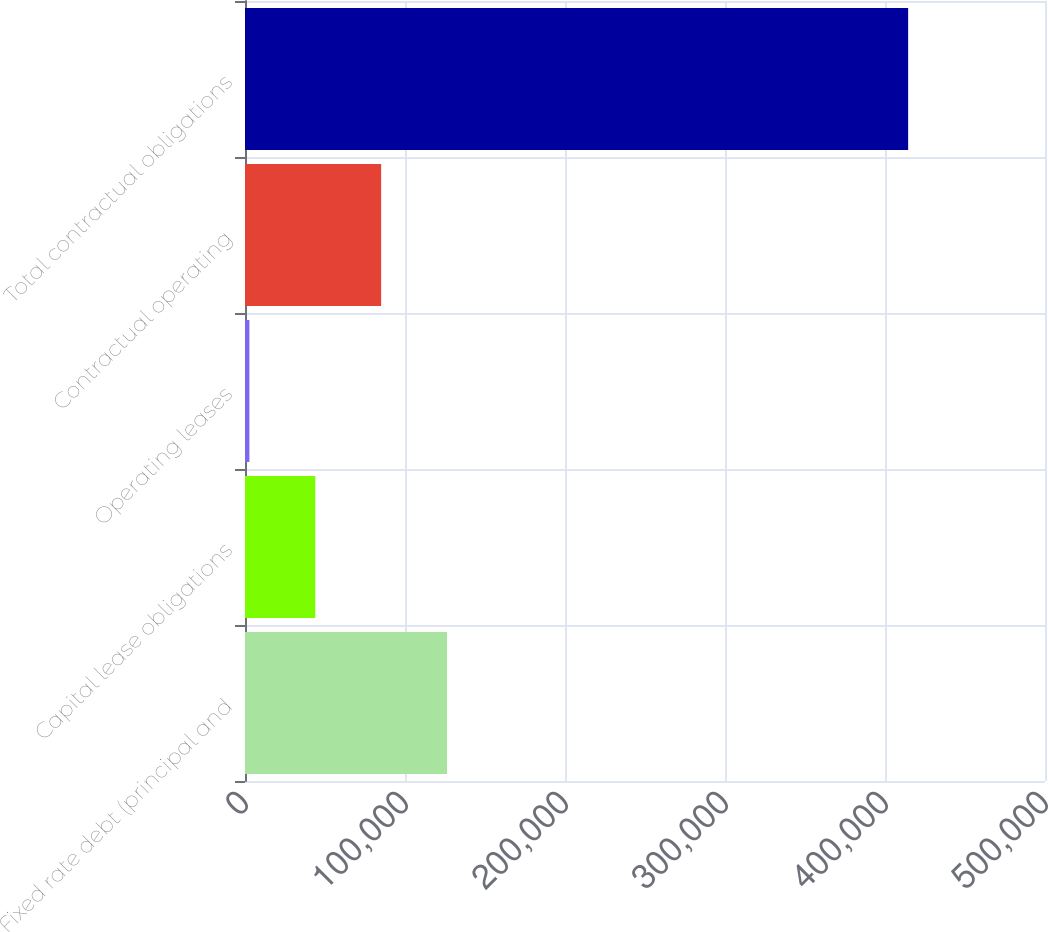Convert chart. <chart><loc_0><loc_0><loc_500><loc_500><bar_chart><fcel>Fixed rate debt (principal and<fcel>Capital lease obligations<fcel>Operating leases<fcel>Contractual operating<fcel>Total contractual obligations<nl><fcel>126265<fcel>43921.8<fcel>2750<fcel>85093.6<fcel>414468<nl></chart> 